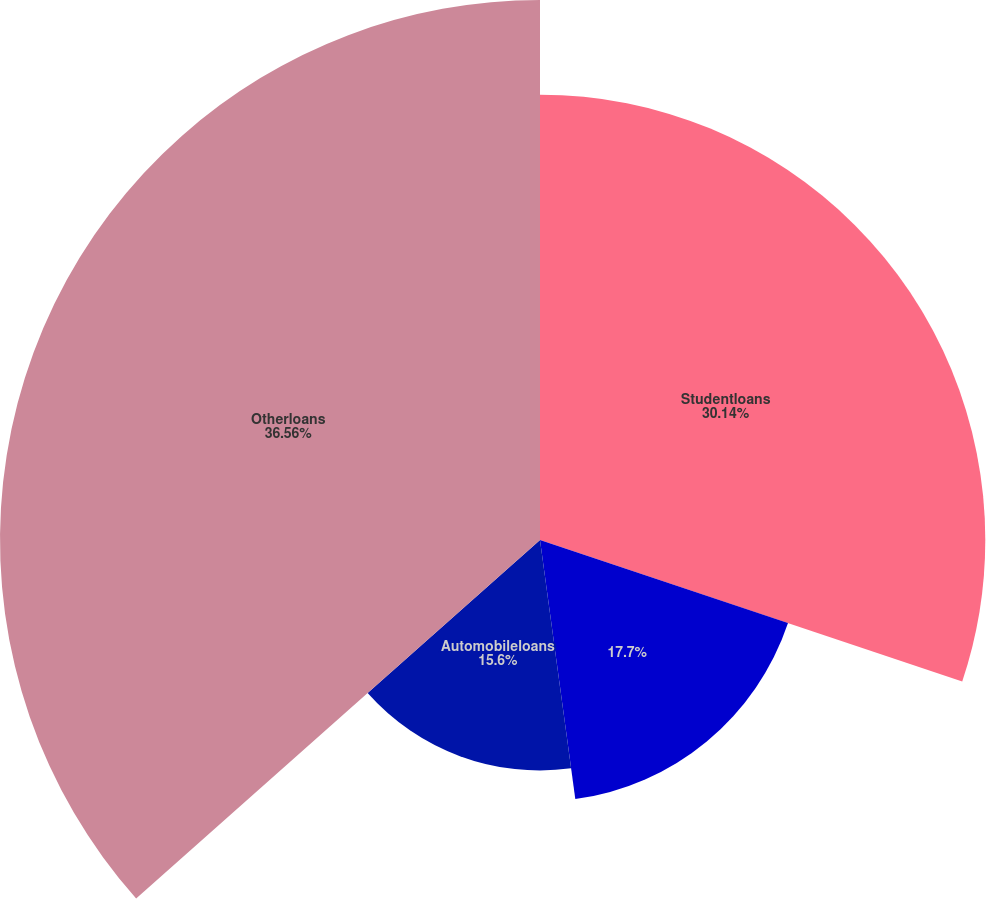Convert chart to OTSL. <chart><loc_0><loc_0><loc_500><loc_500><pie_chart><fcel>Studentloans<fcel>Unnamed: 1<fcel>Automobileloans<fcel>Otherloans<nl><fcel>30.14%<fcel>17.7%<fcel>15.6%<fcel>36.55%<nl></chart> 